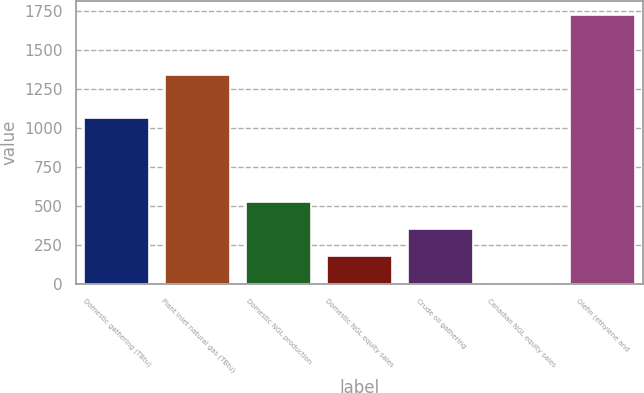<chart> <loc_0><loc_0><loc_500><loc_500><bar_chart><fcel>Domestic gathering (TBtu)<fcel>Plant inlet natural gas (TBtu)<fcel>Domestic NGL production<fcel>Domestic NGL equity sales<fcel>Crude oil gathering<fcel>Canadian NGL equity sales<fcel>Olefin (ethylene and<nl><fcel>1068<fcel>1342<fcel>524<fcel>180<fcel>352<fcel>8<fcel>1728<nl></chart> 